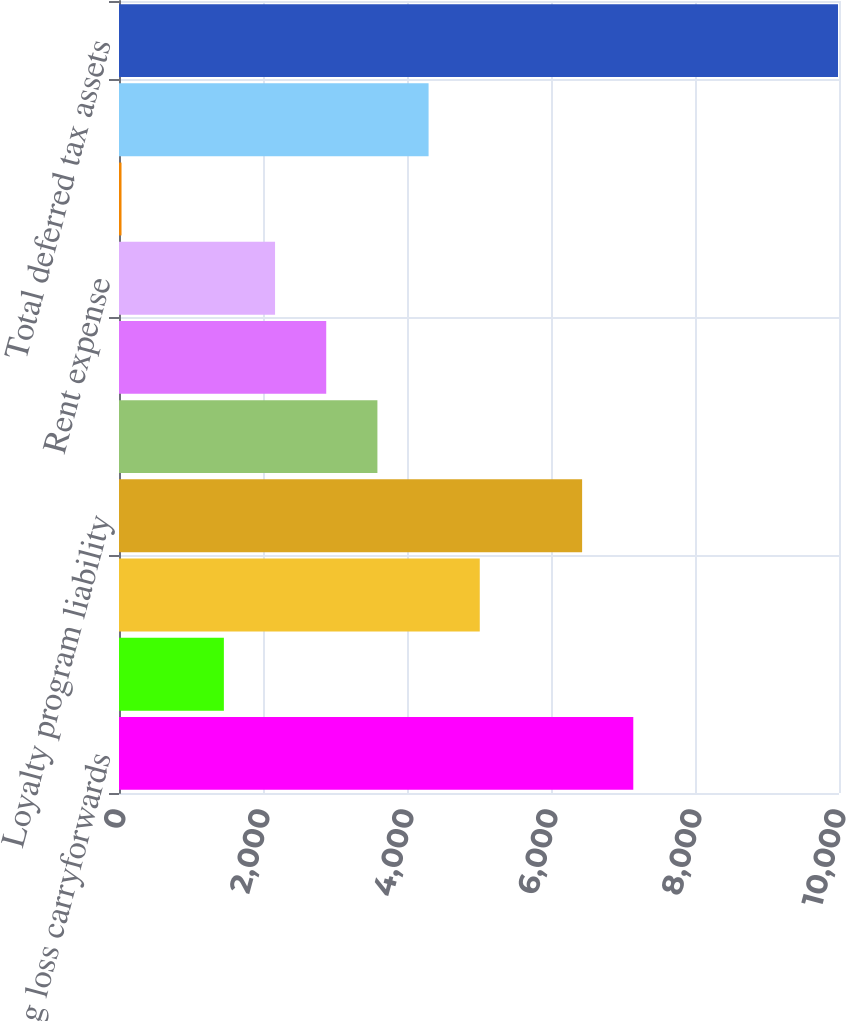Convert chart to OTSL. <chart><loc_0><loc_0><loc_500><loc_500><bar_chart><fcel>Operating loss carryforwards<fcel>Leases<fcel>Pensions<fcel>Loyalty program liability<fcel>Alternative minimum tax (AMT)<fcel>Postretirement benefits other<fcel>Rent expense<fcel>Reorganization items<fcel>Other<fcel>Total deferred tax assets<nl><fcel>7143<fcel>1456.6<fcel>5010.6<fcel>6432.2<fcel>3589<fcel>2878.2<fcel>2167.4<fcel>35<fcel>4299.8<fcel>9986.2<nl></chart> 